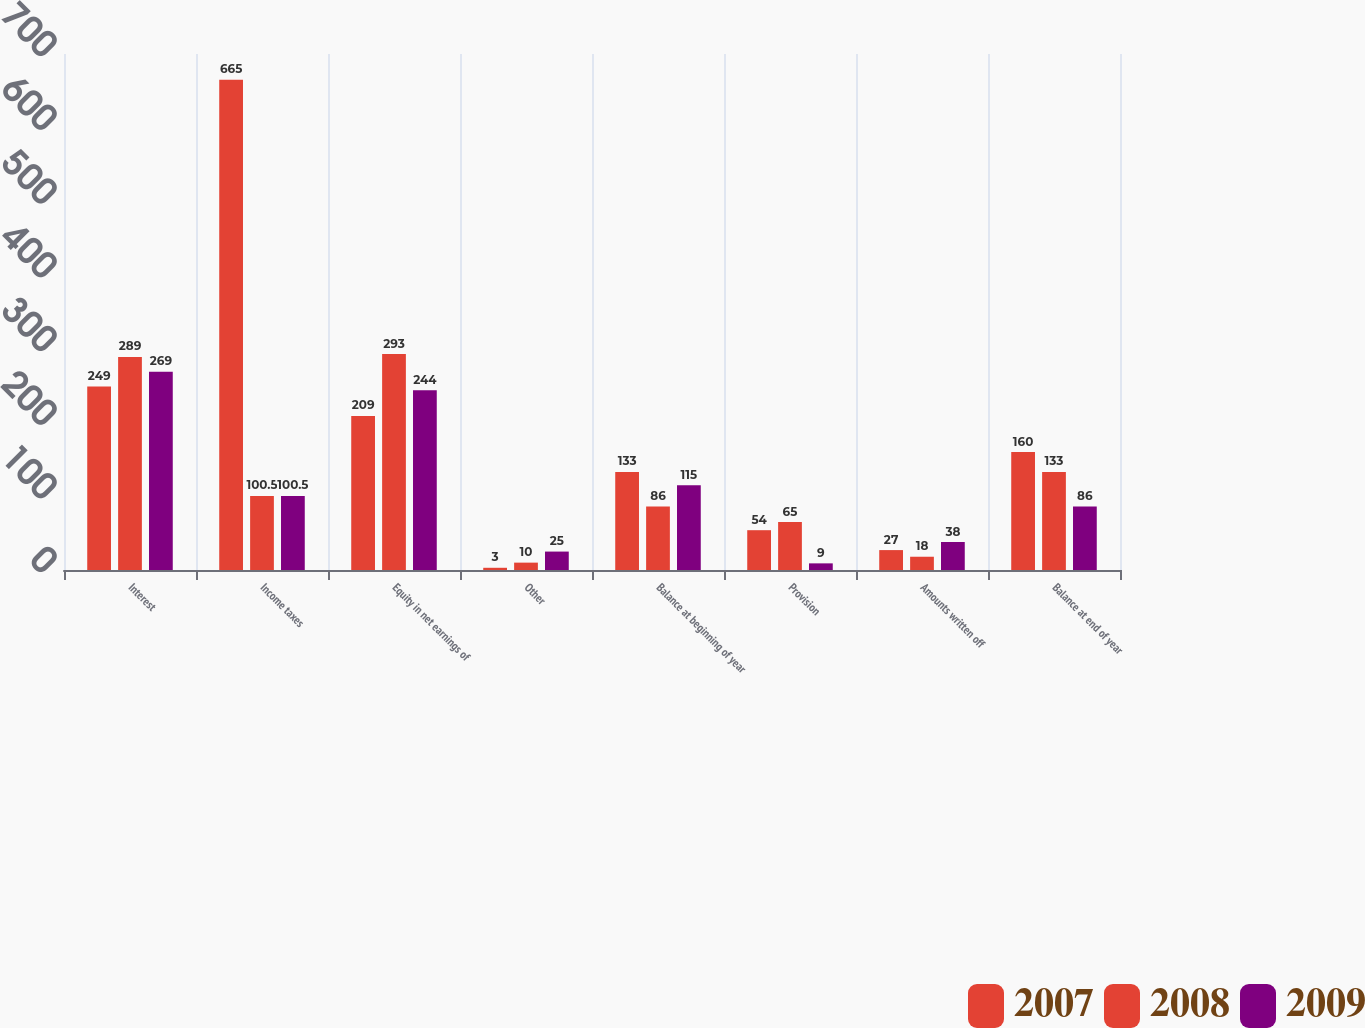Convert chart. <chart><loc_0><loc_0><loc_500><loc_500><stacked_bar_chart><ecel><fcel>Interest<fcel>Income taxes<fcel>Equity in net earnings of<fcel>Other<fcel>Balance at beginning of year<fcel>Provision<fcel>Amounts written off<fcel>Balance at end of year<nl><fcel>2007<fcel>249<fcel>665<fcel>209<fcel>3<fcel>133<fcel>54<fcel>27<fcel>160<nl><fcel>2008<fcel>289<fcel>100.5<fcel>293<fcel>10<fcel>86<fcel>65<fcel>18<fcel>133<nl><fcel>2009<fcel>269<fcel>100.5<fcel>244<fcel>25<fcel>115<fcel>9<fcel>38<fcel>86<nl></chart> 